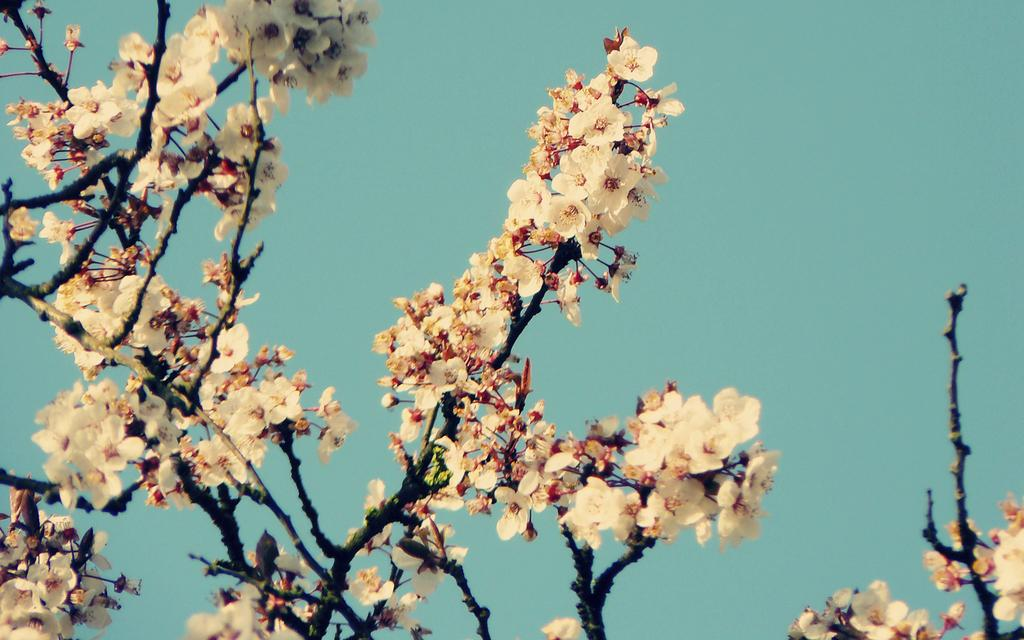What type of plant is visible in the image? There are flowers with stems in the image. What can be seen in the background of the image? The sky is visible in the background of the image. How many oranges are being used to play volleyball in the image? There are no oranges or volleyball present in the image. 